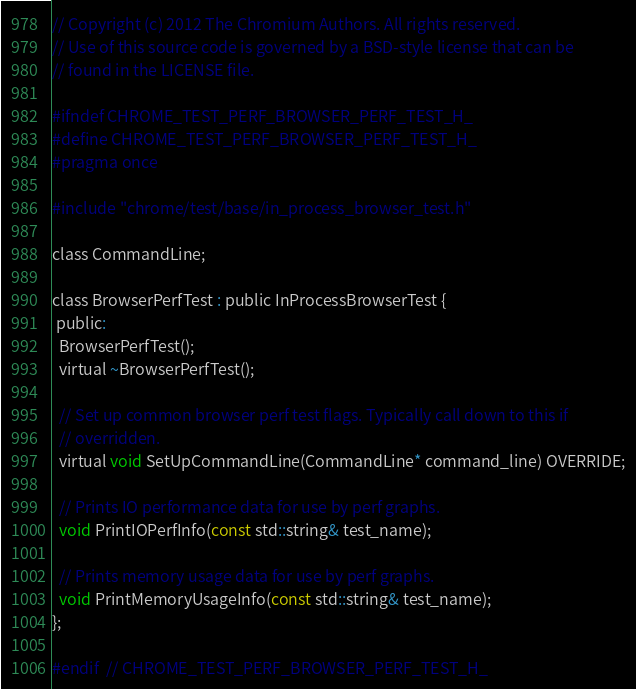<code> <loc_0><loc_0><loc_500><loc_500><_C_>// Copyright (c) 2012 The Chromium Authors. All rights reserved.
// Use of this source code is governed by a BSD-style license that can be
// found in the LICENSE file.

#ifndef CHROME_TEST_PERF_BROWSER_PERF_TEST_H_
#define CHROME_TEST_PERF_BROWSER_PERF_TEST_H_
#pragma once

#include "chrome/test/base/in_process_browser_test.h"

class CommandLine;

class BrowserPerfTest : public InProcessBrowserTest {
 public:
  BrowserPerfTest();
  virtual ~BrowserPerfTest();

  // Set up common browser perf test flags. Typically call down to this if
  // overridden.
  virtual void SetUpCommandLine(CommandLine* command_line) OVERRIDE;

  // Prints IO performance data for use by perf graphs.
  void PrintIOPerfInfo(const std::string& test_name);

  // Prints memory usage data for use by perf graphs.
  void PrintMemoryUsageInfo(const std::string& test_name);
};

#endif  // CHROME_TEST_PERF_BROWSER_PERF_TEST_H_
</code> 